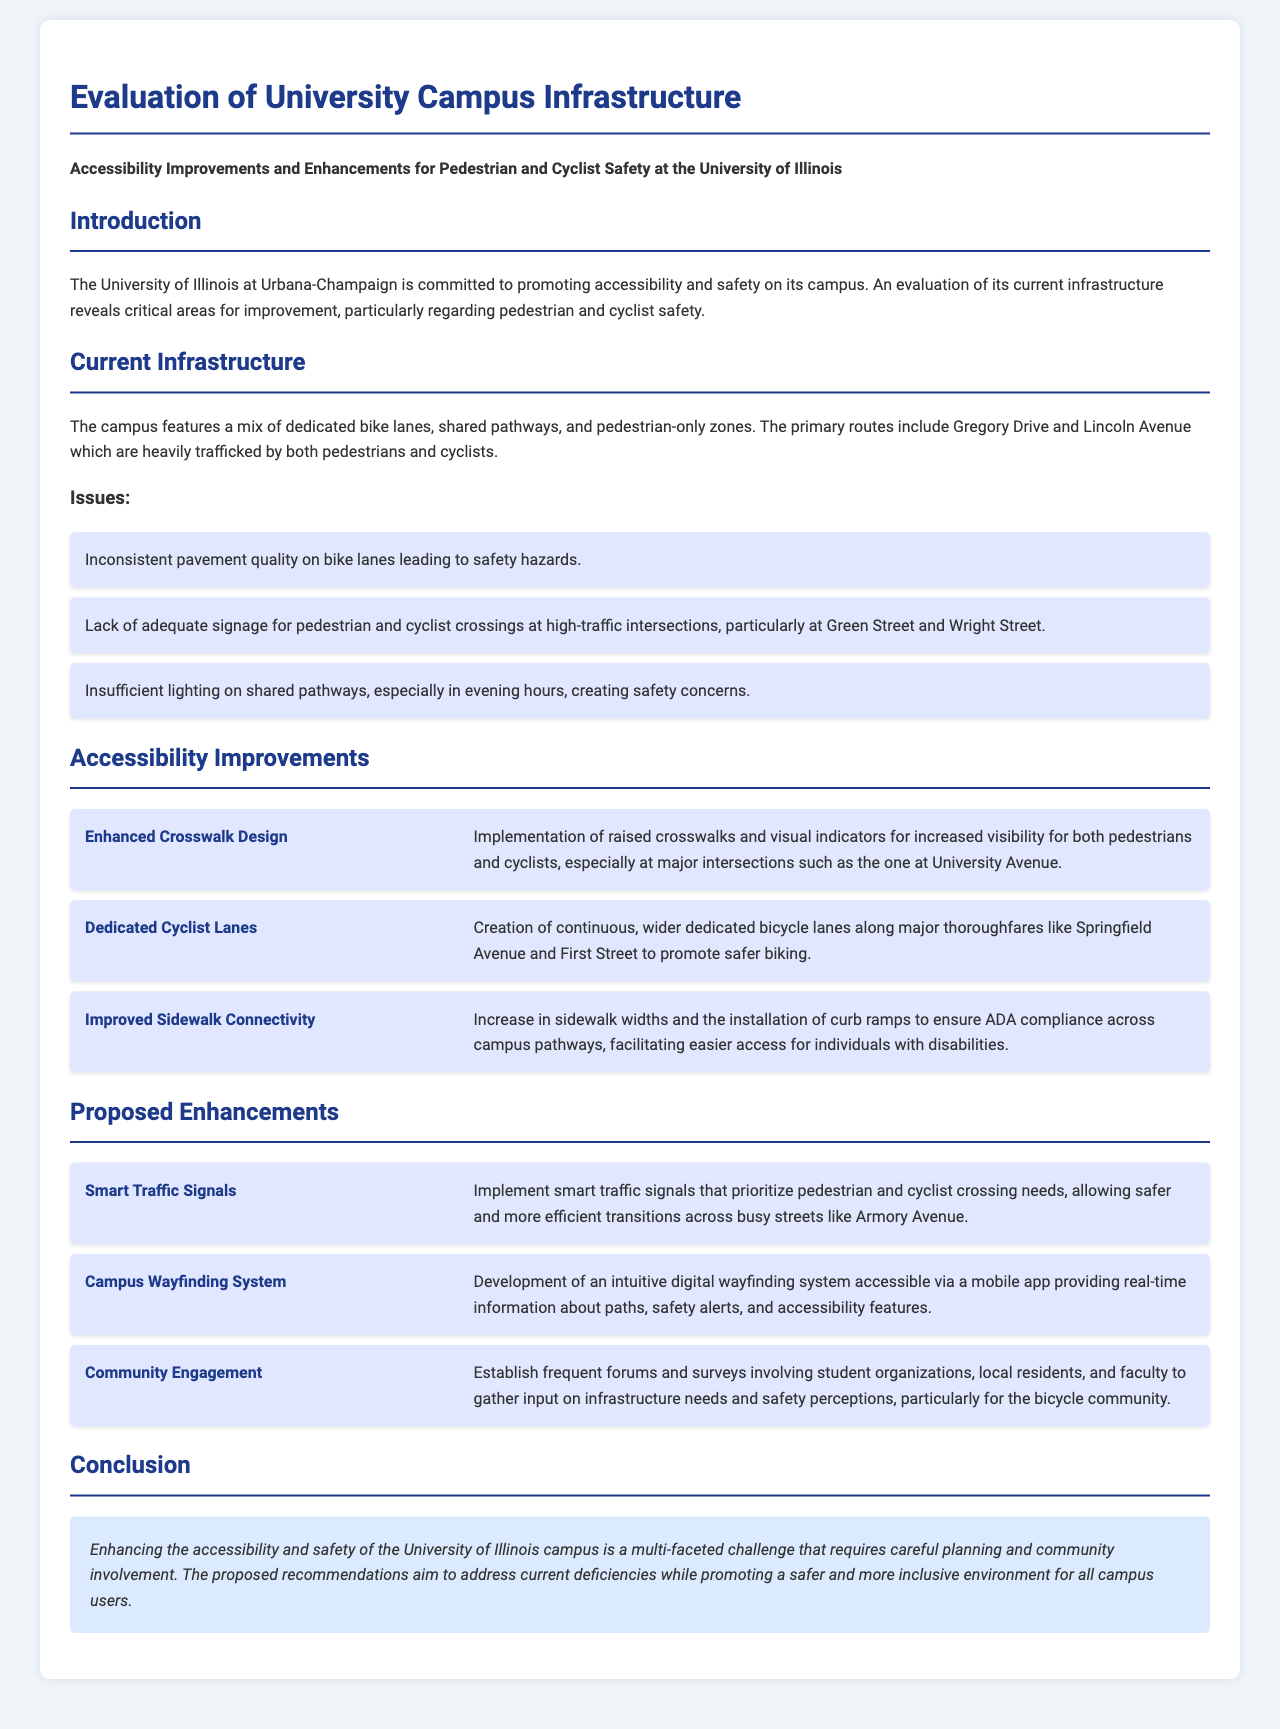What are some of the current infrastructure issues? The list of current infrastructure issues includes inconsistent pavement quality on bike lanes, lack of adequate signage for pedestrian and cyclist crossings, and insufficient lighting on shared pathways.
Answer: Inconsistent pavement quality on bike lanes, lack of adequate signage for pedestrian and cyclist crossings, insufficient lighting on shared pathways What is one proposed enhancement for pedestrian and cyclist safety? The document mentions multiple proposed enhancements, of which one is implementing smart traffic signals to aid crossings.
Answer: Smart traffic signals How many accessibility improvements are listed in the document? The document specifies three accessibility improvements to enhance campus infrastructure.
Answer: Three Which major intersections have adequate signage concerns? The areas where signage for crossings is lacking include high-traffic intersections, particularly at Green Street and Wright Street.
Answer: Green Street and Wright Street What is the purpose of the Community Engagement proposed enhancement? Community Engagement aims to involve students, local residents, and faculty in discussions concerning infrastructure needs and safety perceptions.
Answer: Gather input on infrastructure needs and safety perceptions What improvement is suggested for sidewalk connectivity? The suggested improvement is to increase sidewalk widths and install curb ramps for better accessibility.
Answer: Increase in sidewalk widths and installation of curb ramps What issue does the Enhanced Crosswalk Design address? Enhanced Crosswalk Design specifically addresses visibility concerns for pedestrians and cyclists at major intersections.
Answer: Visibility for both pedestrians and cyclists What is the role of the Campus Wayfinding System? The Campus Wayfinding System is intended to provide real-time information about paths, safety alerts, and accessibility features to campus users.
Answer: Provide real-time information about paths, safety alerts, and accessibility features 